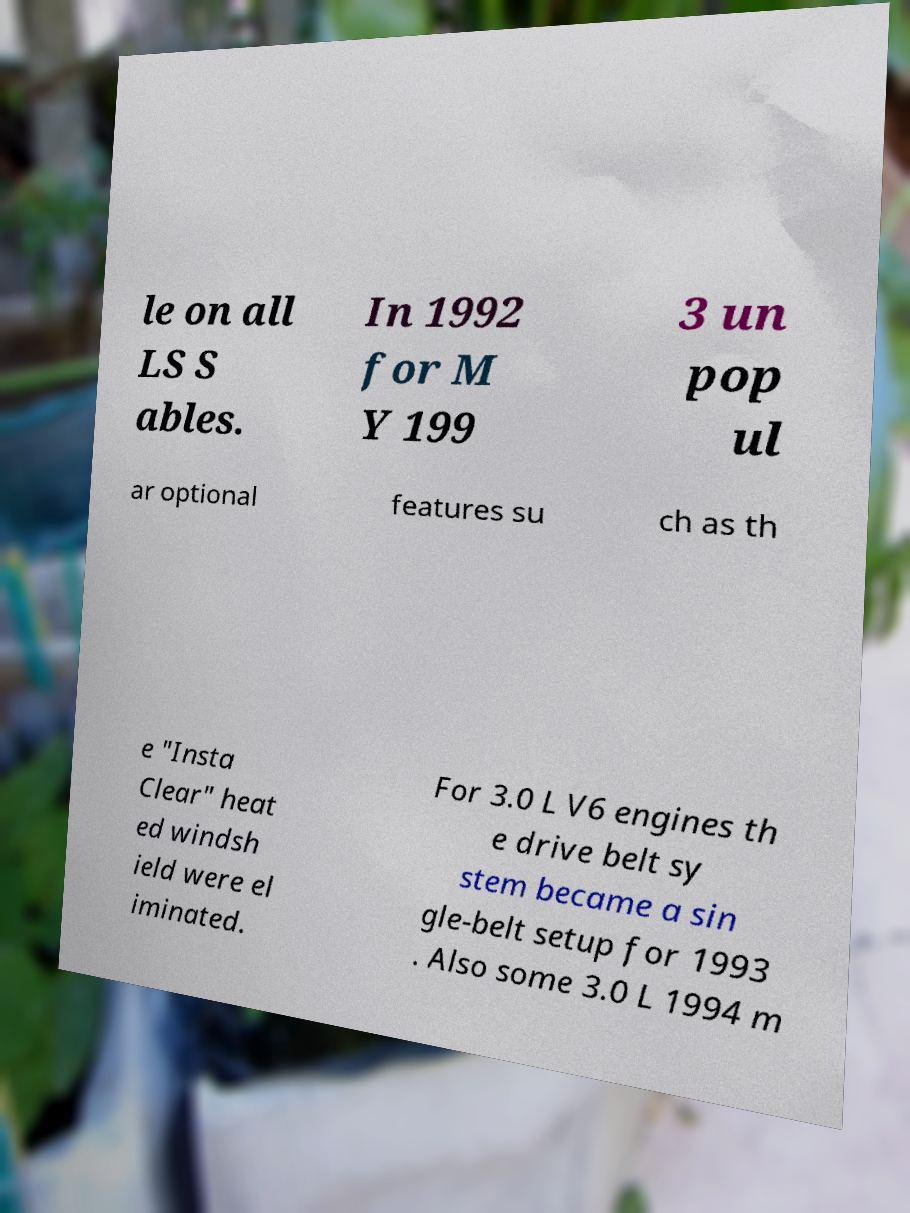For documentation purposes, I need the text within this image transcribed. Could you provide that? le on all LS S ables. In 1992 for M Y 199 3 un pop ul ar optional features su ch as th e "Insta Clear" heat ed windsh ield were el iminated. For 3.0 L V6 engines th e drive belt sy stem became a sin gle-belt setup for 1993 . Also some 3.0 L 1994 m 